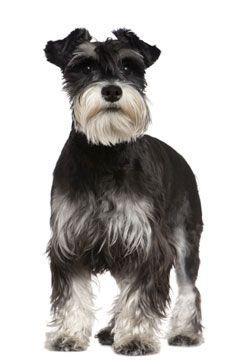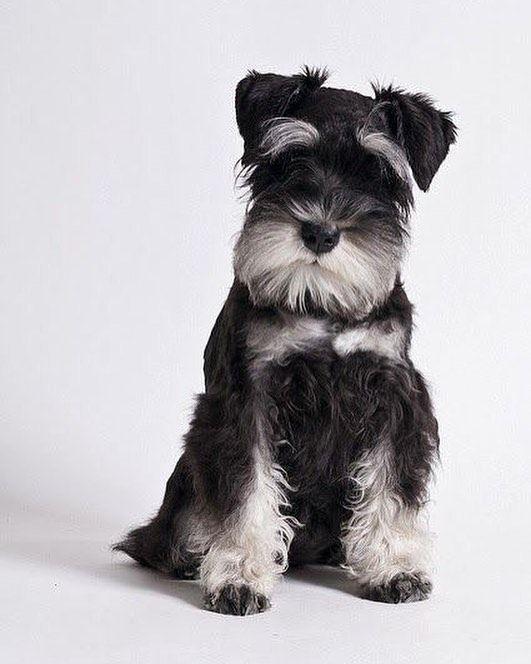The first image is the image on the left, the second image is the image on the right. For the images displayed, is the sentence "There are two dogs sitting down" factually correct? Answer yes or no. No. 